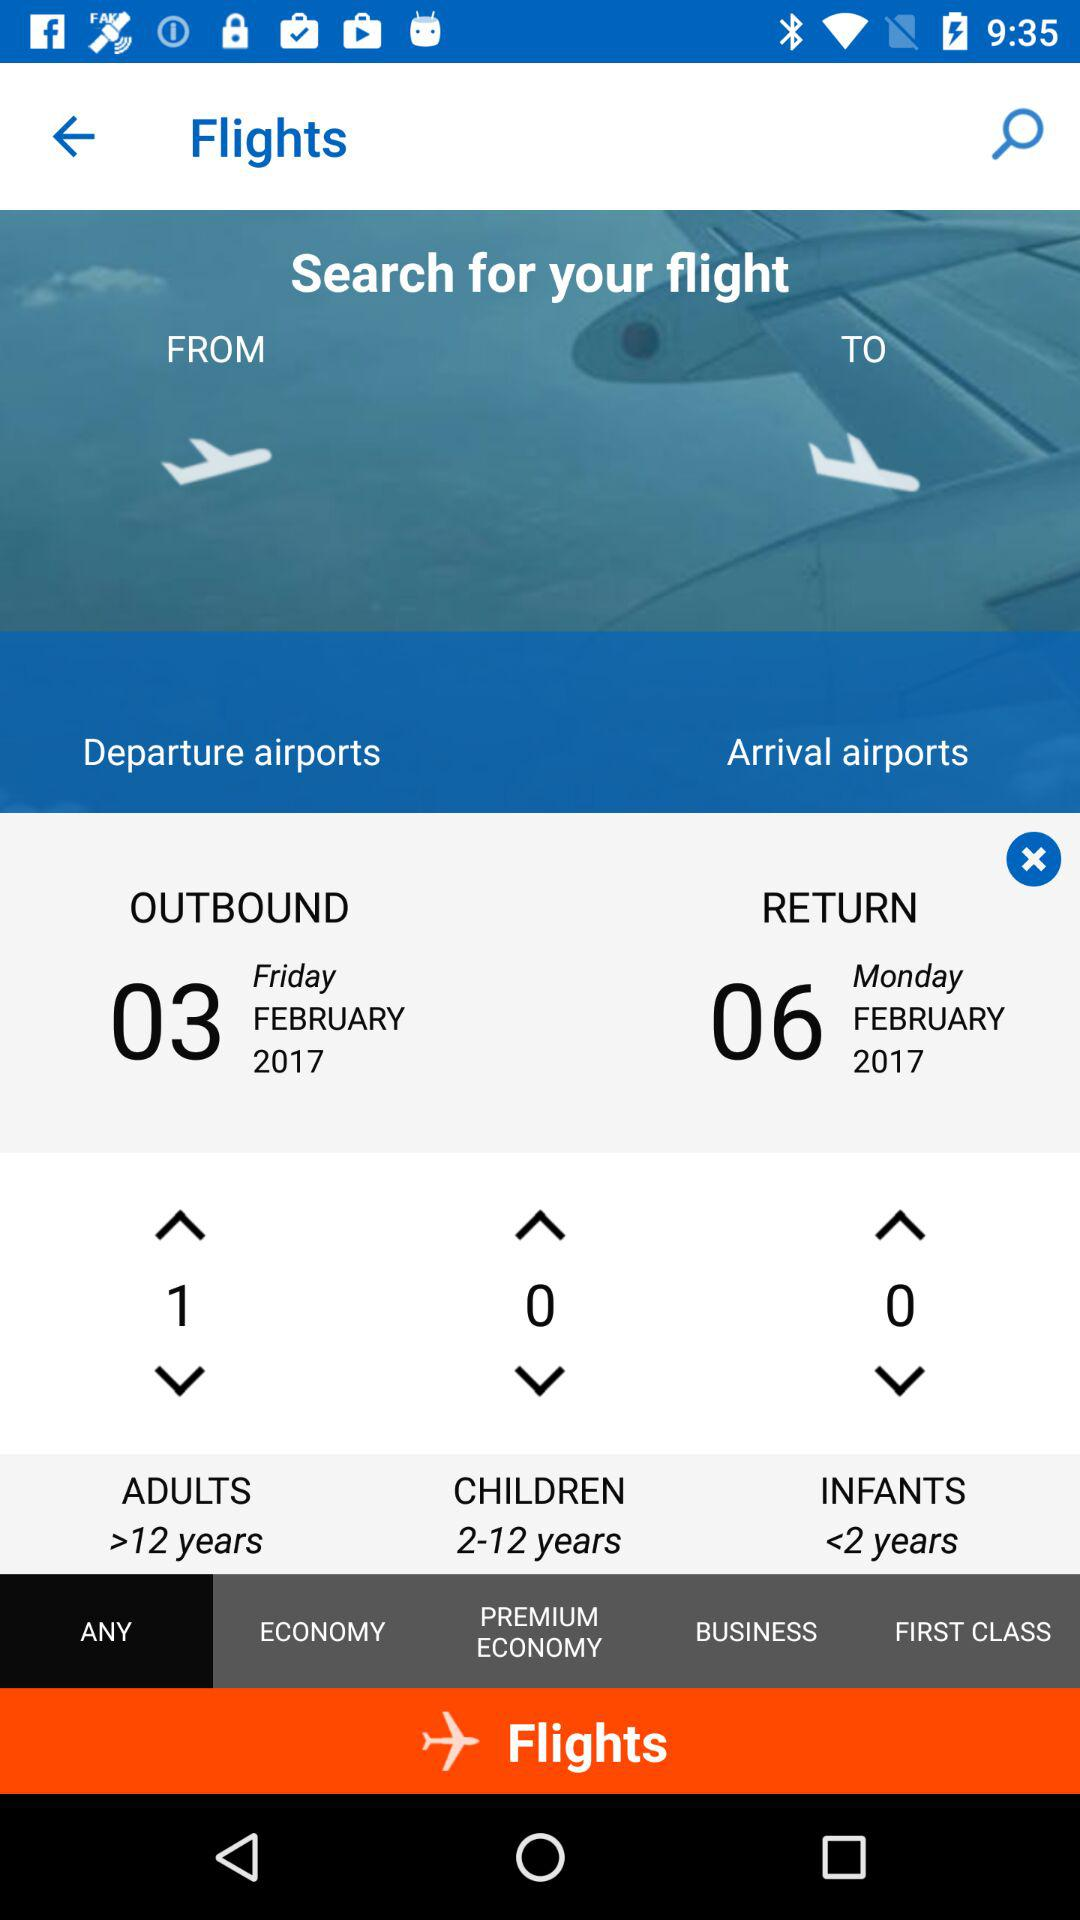How many adults are flying?
Answer the question using a single word or phrase. 1 